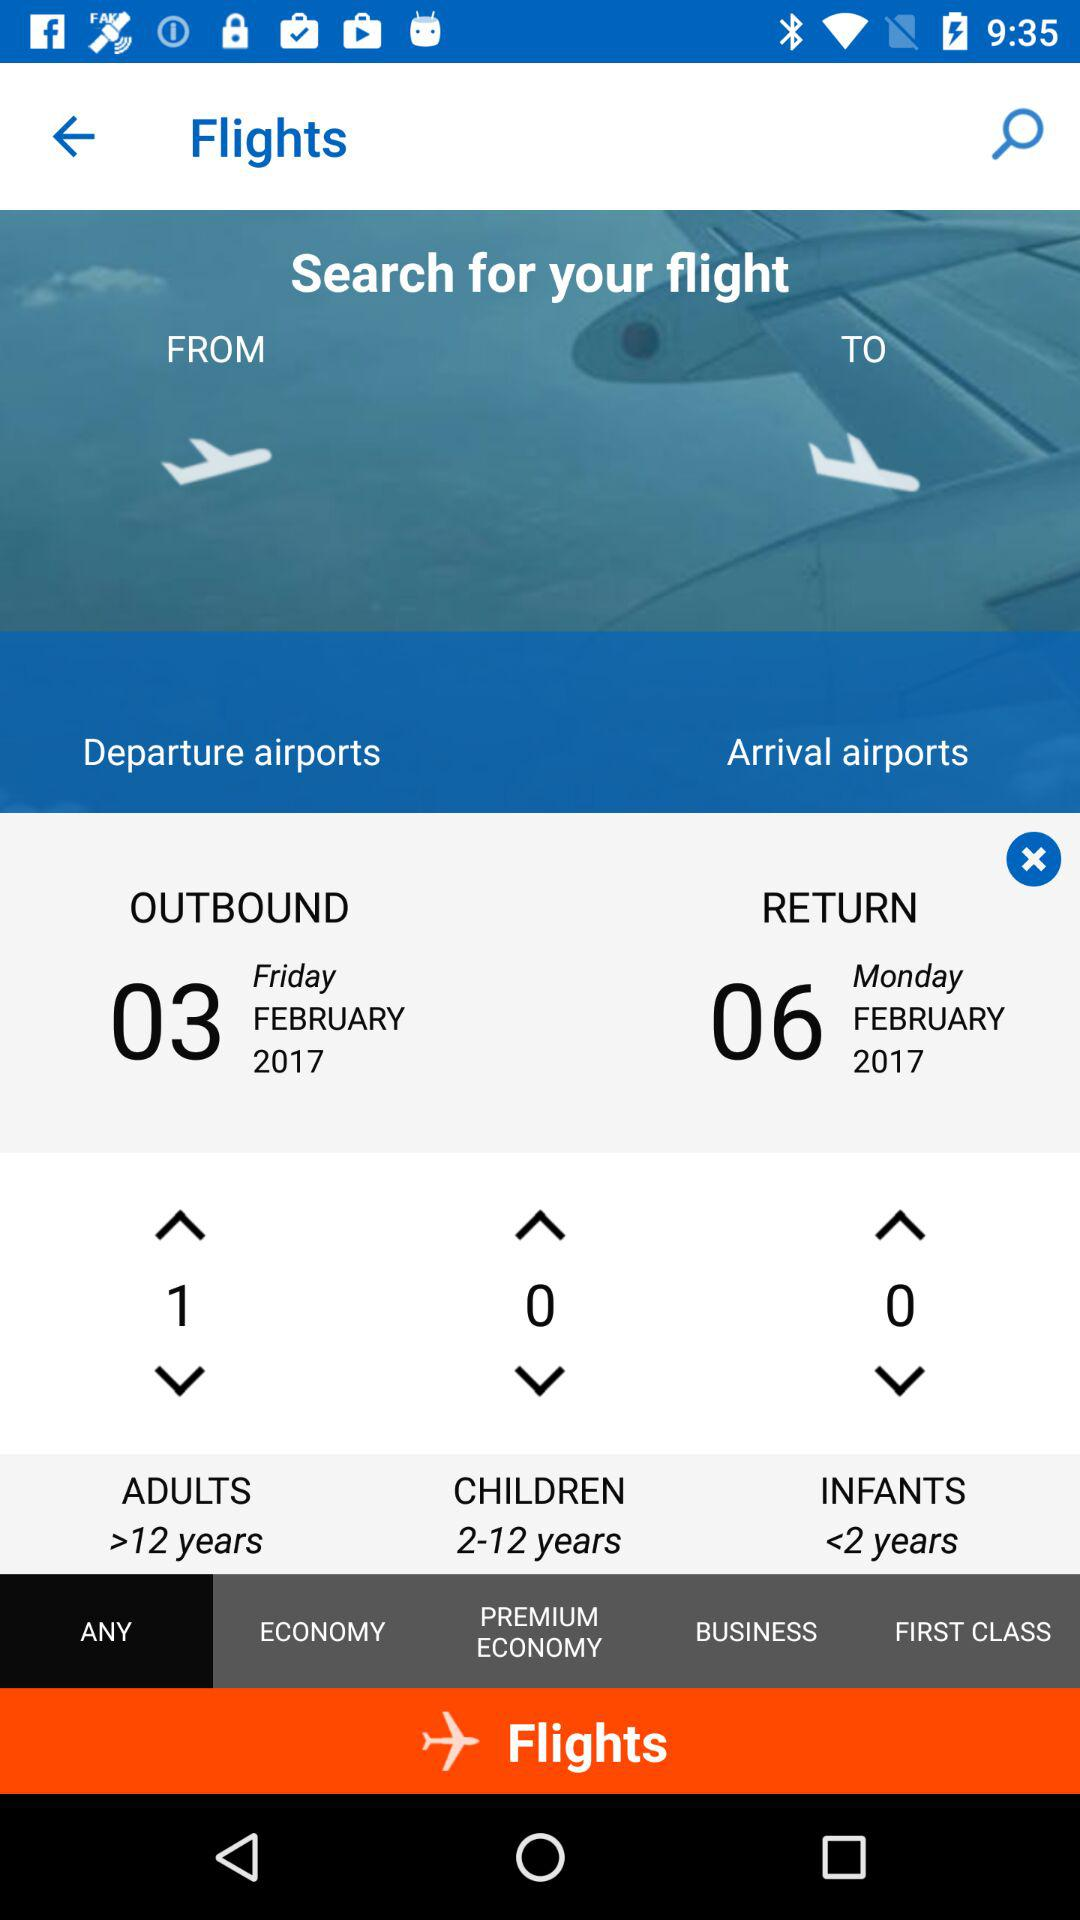How many adults are flying?
Answer the question using a single word or phrase. 1 